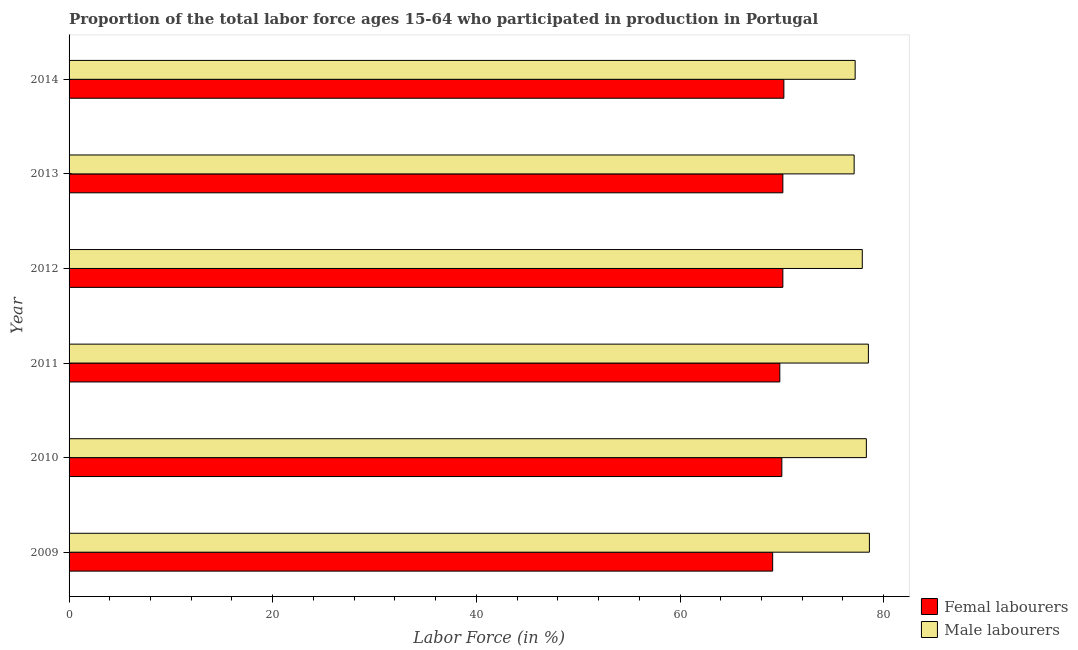Are the number of bars on each tick of the Y-axis equal?
Make the answer very short. Yes. How many bars are there on the 2nd tick from the top?
Ensure brevity in your answer.  2. How many bars are there on the 3rd tick from the bottom?
Keep it short and to the point. 2. What is the label of the 3rd group of bars from the top?
Keep it short and to the point. 2012. In how many cases, is the number of bars for a given year not equal to the number of legend labels?
Your answer should be very brief. 0. What is the percentage of female labor force in 2009?
Offer a terse response. 69.1. Across all years, what is the maximum percentage of male labour force?
Offer a terse response. 78.6. Across all years, what is the minimum percentage of female labor force?
Provide a succinct answer. 69.1. In which year was the percentage of male labour force maximum?
Offer a very short reply. 2009. In which year was the percentage of female labor force minimum?
Make the answer very short. 2009. What is the total percentage of female labor force in the graph?
Keep it short and to the point. 419.3. What is the difference between the percentage of female labor force in 2012 and that in 2014?
Offer a terse response. -0.1. What is the difference between the percentage of female labor force in 2012 and the percentage of male labour force in 2014?
Make the answer very short. -7.1. What is the average percentage of male labour force per year?
Ensure brevity in your answer.  77.93. In how many years, is the percentage of female labor force greater than 20 %?
Provide a short and direct response. 6. Is the difference between the percentage of male labour force in 2010 and 2012 greater than the difference between the percentage of female labor force in 2010 and 2012?
Make the answer very short. Yes. In how many years, is the percentage of male labour force greater than the average percentage of male labour force taken over all years?
Provide a succinct answer. 3. What does the 1st bar from the top in 2011 represents?
Your answer should be compact. Male labourers. What does the 2nd bar from the bottom in 2011 represents?
Offer a very short reply. Male labourers. Are all the bars in the graph horizontal?
Offer a terse response. Yes. What is the difference between two consecutive major ticks on the X-axis?
Provide a succinct answer. 20. Are the values on the major ticks of X-axis written in scientific E-notation?
Ensure brevity in your answer.  No. Does the graph contain any zero values?
Provide a short and direct response. No. Does the graph contain grids?
Ensure brevity in your answer.  No. What is the title of the graph?
Ensure brevity in your answer.  Proportion of the total labor force ages 15-64 who participated in production in Portugal. What is the label or title of the X-axis?
Offer a very short reply. Labor Force (in %). What is the label or title of the Y-axis?
Your answer should be very brief. Year. What is the Labor Force (in %) of Femal labourers in 2009?
Your answer should be compact. 69.1. What is the Labor Force (in %) of Male labourers in 2009?
Provide a short and direct response. 78.6. What is the Labor Force (in %) of Femal labourers in 2010?
Your answer should be compact. 70. What is the Labor Force (in %) of Male labourers in 2010?
Give a very brief answer. 78.3. What is the Labor Force (in %) of Femal labourers in 2011?
Give a very brief answer. 69.8. What is the Labor Force (in %) of Male labourers in 2011?
Provide a succinct answer. 78.5. What is the Labor Force (in %) of Femal labourers in 2012?
Provide a succinct answer. 70.1. What is the Labor Force (in %) in Male labourers in 2012?
Offer a very short reply. 77.9. What is the Labor Force (in %) in Femal labourers in 2013?
Your response must be concise. 70.1. What is the Labor Force (in %) of Male labourers in 2013?
Keep it short and to the point. 77.1. What is the Labor Force (in %) in Femal labourers in 2014?
Your answer should be compact. 70.2. What is the Labor Force (in %) in Male labourers in 2014?
Your answer should be compact. 77.2. Across all years, what is the maximum Labor Force (in %) in Femal labourers?
Keep it short and to the point. 70.2. Across all years, what is the maximum Labor Force (in %) of Male labourers?
Make the answer very short. 78.6. Across all years, what is the minimum Labor Force (in %) of Femal labourers?
Offer a terse response. 69.1. Across all years, what is the minimum Labor Force (in %) of Male labourers?
Provide a short and direct response. 77.1. What is the total Labor Force (in %) in Femal labourers in the graph?
Your response must be concise. 419.3. What is the total Labor Force (in %) of Male labourers in the graph?
Keep it short and to the point. 467.6. What is the difference between the Labor Force (in %) of Femal labourers in 2009 and that in 2010?
Provide a short and direct response. -0.9. What is the difference between the Labor Force (in %) of Male labourers in 2009 and that in 2010?
Ensure brevity in your answer.  0.3. What is the difference between the Labor Force (in %) in Femal labourers in 2009 and that in 2011?
Offer a very short reply. -0.7. What is the difference between the Labor Force (in %) of Male labourers in 2009 and that in 2011?
Give a very brief answer. 0.1. What is the difference between the Labor Force (in %) in Femal labourers in 2009 and that in 2012?
Give a very brief answer. -1. What is the difference between the Labor Force (in %) of Femal labourers in 2009 and that in 2013?
Your response must be concise. -1. What is the difference between the Labor Force (in %) of Male labourers in 2009 and that in 2013?
Give a very brief answer. 1.5. What is the difference between the Labor Force (in %) in Femal labourers in 2009 and that in 2014?
Provide a succinct answer. -1.1. What is the difference between the Labor Force (in %) in Femal labourers in 2010 and that in 2011?
Make the answer very short. 0.2. What is the difference between the Labor Force (in %) of Femal labourers in 2010 and that in 2012?
Offer a very short reply. -0.1. What is the difference between the Labor Force (in %) in Male labourers in 2010 and that in 2012?
Give a very brief answer. 0.4. What is the difference between the Labor Force (in %) in Male labourers in 2010 and that in 2013?
Make the answer very short. 1.2. What is the difference between the Labor Force (in %) of Femal labourers in 2010 and that in 2014?
Your answer should be compact. -0.2. What is the difference between the Labor Force (in %) of Femal labourers in 2011 and that in 2012?
Give a very brief answer. -0.3. What is the difference between the Labor Force (in %) of Femal labourers in 2012 and that in 2013?
Offer a terse response. 0. What is the difference between the Labor Force (in %) in Male labourers in 2012 and that in 2013?
Ensure brevity in your answer.  0.8. What is the difference between the Labor Force (in %) of Male labourers in 2012 and that in 2014?
Provide a succinct answer. 0.7. What is the difference between the Labor Force (in %) in Femal labourers in 2013 and that in 2014?
Provide a succinct answer. -0.1. What is the difference between the Labor Force (in %) of Male labourers in 2013 and that in 2014?
Keep it short and to the point. -0.1. What is the difference between the Labor Force (in %) in Femal labourers in 2009 and the Labor Force (in %) in Male labourers in 2013?
Give a very brief answer. -8. What is the difference between the Labor Force (in %) of Femal labourers in 2009 and the Labor Force (in %) of Male labourers in 2014?
Make the answer very short. -8.1. What is the difference between the Labor Force (in %) in Femal labourers in 2010 and the Labor Force (in %) in Male labourers in 2011?
Keep it short and to the point. -8.5. What is the difference between the Labor Force (in %) of Femal labourers in 2010 and the Labor Force (in %) of Male labourers in 2014?
Give a very brief answer. -7.2. What is the difference between the Labor Force (in %) of Femal labourers in 2011 and the Labor Force (in %) of Male labourers in 2014?
Keep it short and to the point. -7.4. What is the difference between the Labor Force (in %) in Femal labourers in 2012 and the Labor Force (in %) in Male labourers in 2013?
Your response must be concise. -7. What is the average Labor Force (in %) of Femal labourers per year?
Offer a terse response. 69.88. What is the average Labor Force (in %) of Male labourers per year?
Give a very brief answer. 77.93. In the year 2010, what is the difference between the Labor Force (in %) of Femal labourers and Labor Force (in %) of Male labourers?
Offer a terse response. -8.3. In the year 2011, what is the difference between the Labor Force (in %) in Femal labourers and Labor Force (in %) in Male labourers?
Keep it short and to the point. -8.7. In the year 2012, what is the difference between the Labor Force (in %) in Femal labourers and Labor Force (in %) in Male labourers?
Offer a very short reply. -7.8. In the year 2014, what is the difference between the Labor Force (in %) of Femal labourers and Labor Force (in %) of Male labourers?
Provide a short and direct response. -7. What is the ratio of the Labor Force (in %) in Femal labourers in 2009 to that in 2010?
Your answer should be compact. 0.99. What is the ratio of the Labor Force (in %) in Male labourers in 2009 to that in 2010?
Offer a terse response. 1. What is the ratio of the Labor Force (in %) in Femal labourers in 2009 to that in 2012?
Keep it short and to the point. 0.99. What is the ratio of the Labor Force (in %) of Femal labourers in 2009 to that in 2013?
Your response must be concise. 0.99. What is the ratio of the Labor Force (in %) in Male labourers in 2009 to that in 2013?
Your answer should be very brief. 1.02. What is the ratio of the Labor Force (in %) in Femal labourers in 2009 to that in 2014?
Your answer should be very brief. 0.98. What is the ratio of the Labor Force (in %) in Male labourers in 2009 to that in 2014?
Your answer should be compact. 1.02. What is the ratio of the Labor Force (in %) of Femal labourers in 2010 to that in 2011?
Give a very brief answer. 1. What is the ratio of the Labor Force (in %) in Male labourers in 2010 to that in 2011?
Your answer should be very brief. 1. What is the ratio of the Labor Force (in %) in Male labourers in 2010 to that in 2012?
Offer a terse response. 1.01. What is the ratio of the Labor Force (in %) in Femal labourers in 2010 to that in 2013?
Ensure brevity in your answer.  1. What is the ratio of the Labor Force (in %) of Male labourers in 2010 to that in 2013?
Offer a terse response. 1.02. What is the ratio of the Labor Force (in %) in Male labourers in 2010 to that in 2014?
Give a very brief answer. 1.01. What is the ratio of the Labor Force (in %) in Male labourers in 2011 to that in 2012?
Ensure brevity in your answer.  1.01. What is the ratio of the Labor Force (in %) in Male labourers in 2011 to that in 2013?
Provide a succinct answer. 1.02. What is the ratio of the Labor Force (in %) of Male labourers in 2011 to that in 2014?
Your response must be concise. 1.02. What is the ratio of the Labor Force (in %) of Male labourers in 2012 to that in 2013?
Offer a very short reply. 1.01. What is the ratio of the Labor Force (in %) of Male labourers in 2012 to that in 2014?
Give a very brief answer. 1.01. What is the difference between the highest and the lowest Labor Force (in %) of Femal labourers?
Your answer should be very brief. 1.1. 